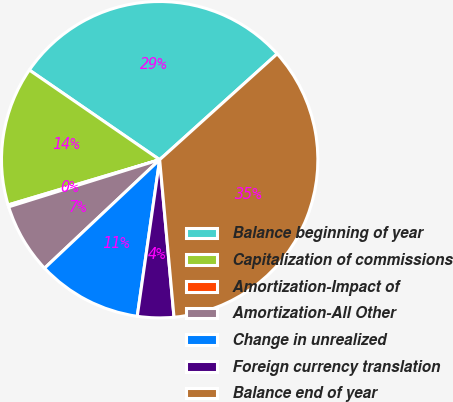<chart> <loc_0><loc_0><loc_500><loc_500><pie_chart><fcel>Balance beginning of year<fcel>Capitalization of commissions<fcel>Amortization-Impact of<fcel>Amortization-All Other<fcel>Change in unrealized<fcel>Foreign currency translation<fcel>Balance end of year<nl><fcel>28.74%<fcel>14.21%<fcel>0.2%<fcel>7.21%<fcel>10.71%<fcel>3.71%<fcel>35.23%<nl></chart> 